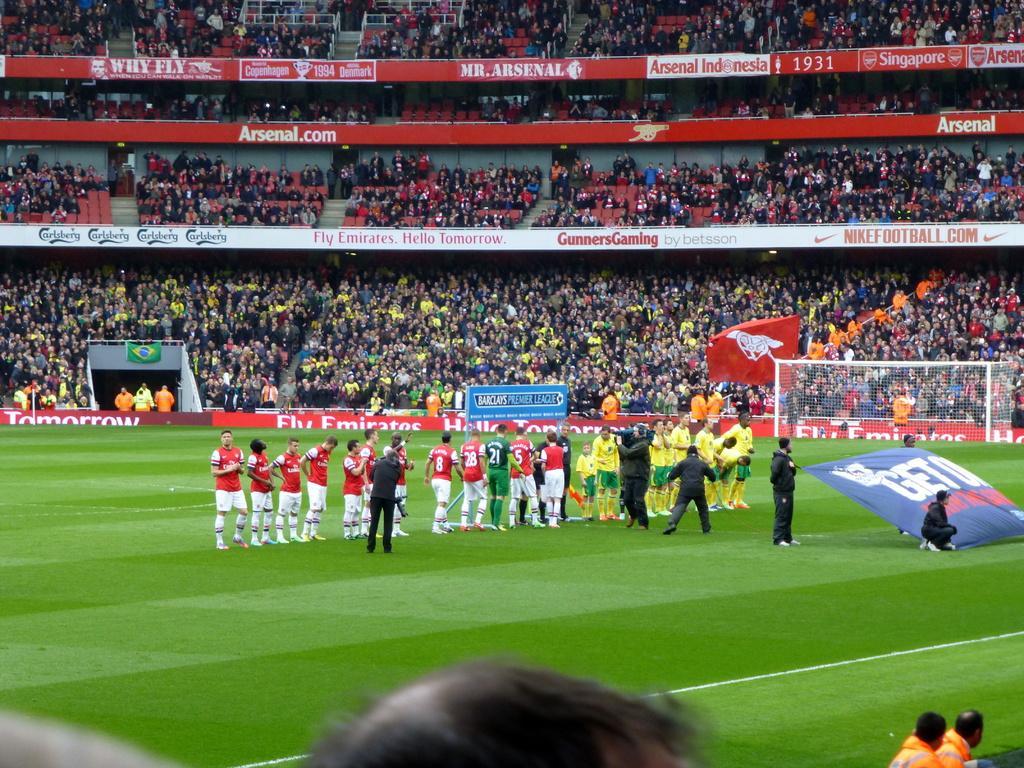Describe this image in one or two sentences. In this image few persons are standing on the ground. Few persons are wearing red shirts, few are wearing yellow shirts and few are wearing black shirts. A person is holding a camera in his hand. Two persons are holding the banner. Few persons are sitting behind the banner. Bottom of image there are few persons. 